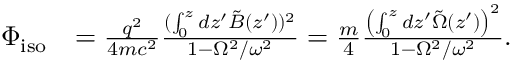<formula> <loc_0><loc_0><loc_500><loc_500>\begin{array} { r l } { \Phi _ { i s o } } & { = \frac { q ^ { 2 } } { 4 m c ^ { 2 } } \frac { ( \int _ { 0 } ^ { z } d z ^ { \prime } \tilde { B } ( z ^ { \prime } ) ) ^ { 2 } } { 1 - \Omega ^ { 2 } / \omega ^ { 2 } } = \frac { m } { 4 } \frac { \left ( \int _ { 0 } ^ { z } d z ^ { \prime } \tilde { \Omega } ( z ^ { \prime } ) \right ) ^ { 2 } } { 1 - \Omega ^ { 2 } / \omega ^ { 2 } } . } \end{array}</formula> 